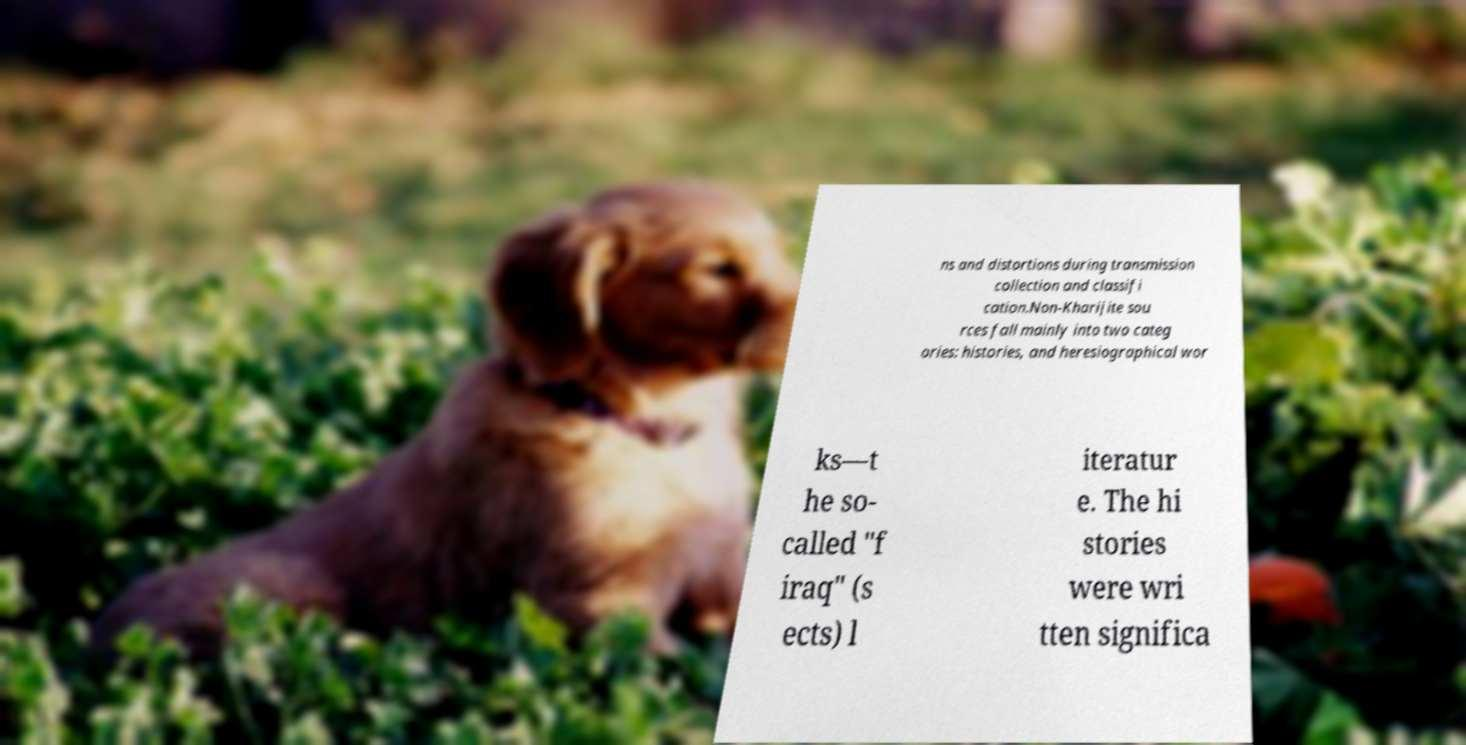For documentation purposes, I need the text within this image transcribed. Could you provide that? ns and distortions during transmission collection and classifi cation.Non-Kharijite sou rces fall mainly into two categ ories: histories, and heresiographical wor ks—t he so- called "f iraq" (s ects) l iteratur e. The hi stories were wri tten significa 